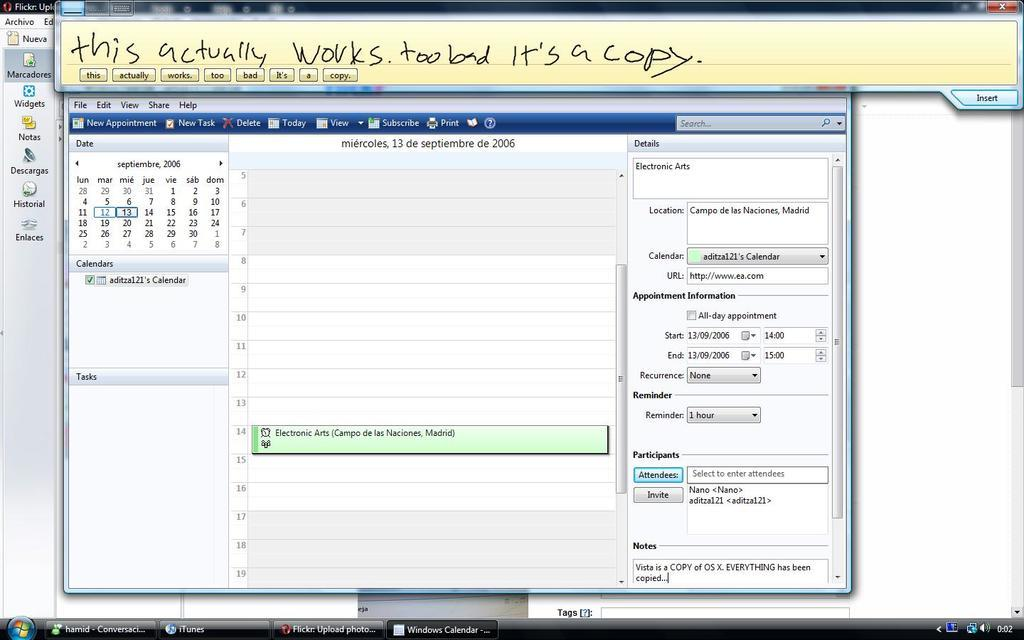<image>
Offer a succinct explanation of the picture presented. A window opened on a computer to schedule something with a note on the top in handwriting saying this actually works too bad its a copy. 